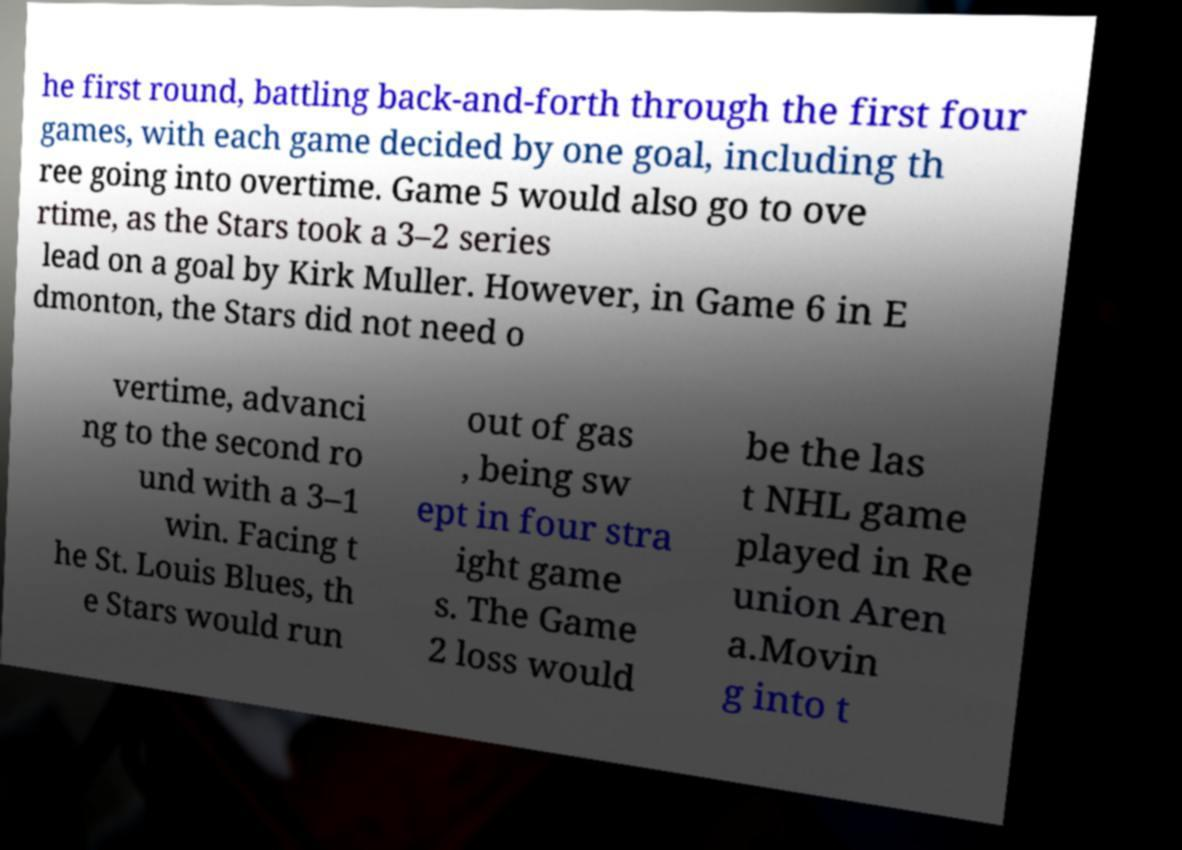Can you accurately transcribe the text from the provided image for me? he first round, battling back-and-forth through the first four games, with each game decided by one goal, including th ree going into overtime. Game 5 would also go to ove rtime, as the Stars took a 3–2 series lead on a goal by Kirk Muller. However, in Game 6 in E dmonton, the Stars did not need o vertime, advanci ng to the second ro und with a 3–1 win. Facing t he St. Louis Blues, th e Stars would run out of gas , being sw ept in four stra ight game s. The Game 2 loss would be the las t NHL game played in Re union Aren a.Movin g into t 